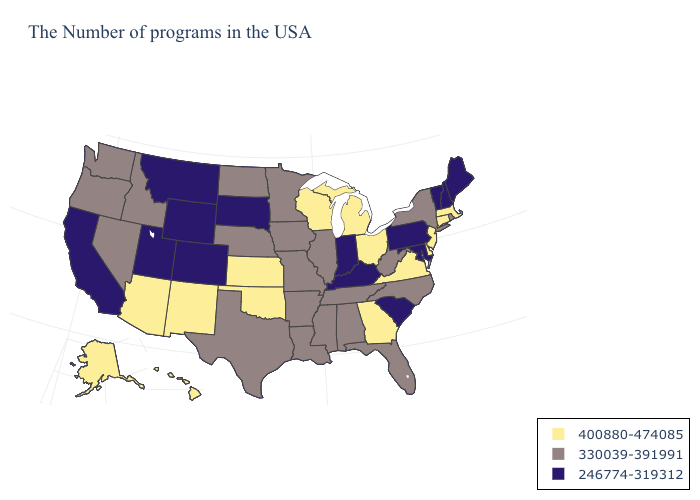Name the states that have a value in the range 330039-391991?
Keep it brief. Rhode Island, New York, North Carolina, West Virginia, Florida, Alabama, Tennessee, Illinois, Mississippi, Louisiana, Missouri, Arkansas, Minnesota, Iowa, Nebraska, Texas, North Dakota, Idaho, Nevada, Washington, Oregon. What is the value of Missouri?
Answer briefly. 330039-391991. What is the value of Iowa?
Concise answer only. 330039-391991. What is the highest value in the Northeast ?
Give a very brief answer. 400880-474085. Does Oklahoma have the lowest value in the USA?
Be succinct. No. Which states have the lowest value in the USA?
Answer briefly. Maine, New Hampshire, Vermont, Maryland, Pennsylvania, South Carolina, Kentucky, Indiana, South Dakota, Wyoming, Colorado, Utah, Montana, California. Name the states that have a value in the range 330039-391991?
Concise answer only. Rhode Island, New York, North Carolina, West Virginia, Florida, Alabama, Tennessee, Illinois, Mississippi, Louisiana, Missouri, Arkansas, Minnesota, Iowa, Nebraska, Texas, North Dakota, Idaho, Nevada, Washington, Oregon. What is the value of Iowa?
Keep it brief. 330039-391991. Does Virginia have the same value as Kentucky?
Write a very short answer. No. Does Virginia have the highest value in the South?
Give a very brief answer. Yes. What is the value of Maine?
Short answer required. 246774-319312. What is the value of Illinois?
Quick response, please. 330039-391991. Which states have the lowest value in the USA?
Write a very short answer. Maine, New Hampshire, Vermont, Maryland, Pennsylvania, South Carolina, Kentucky, Indiana, South Dakota, Wyoming, Colorado, Utah, Montana, California. Among the states that border South Dakota , does Iowa have the highest value?
Write a very short answer. Yes. Name the states that have a value in the range 246774-319312?
Keep it brief. Maine, New Hampshire, Vermont, Maryland, Pennsylvania, South Carolina, Kentucky, Indiana, South Dakota, Wyoming, Colorado, Utah, Montana, California. 